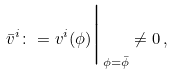<formula> <loc_0><loc_0><loc_500><loc_500>\bar { v } ^ { i } \colon = v ^ { i } ( \phi ) \Big | _ { \phi = \bar { \phi } } \ne 0 \, ,</formula> 